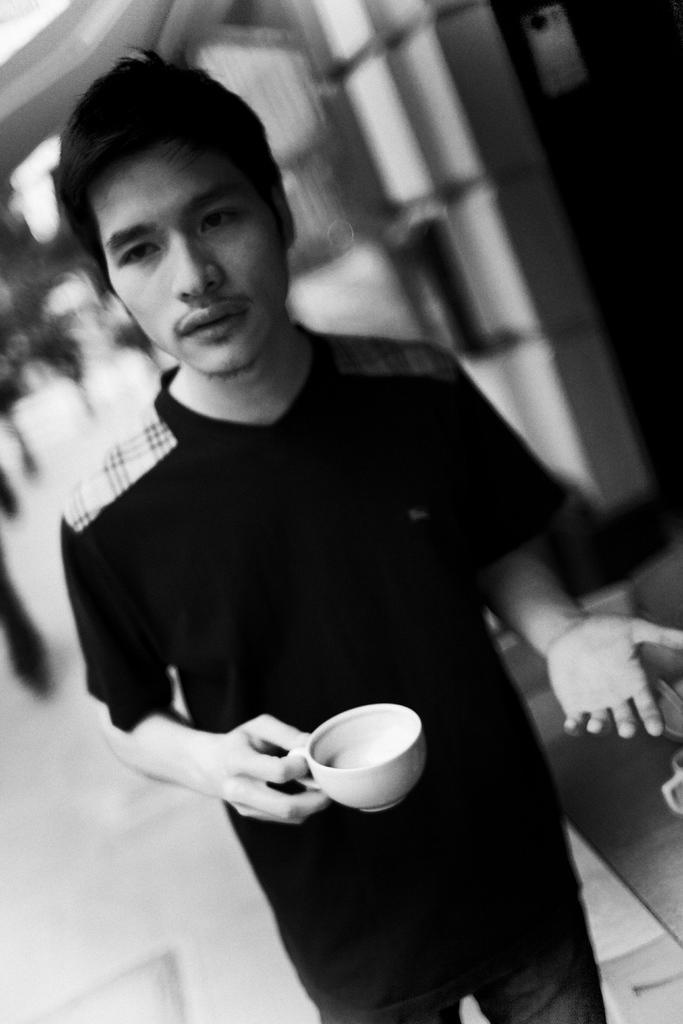Please provide a concise description of this image. IN this picture we can see a person holding a cup in his right hand wearing black shirt. 